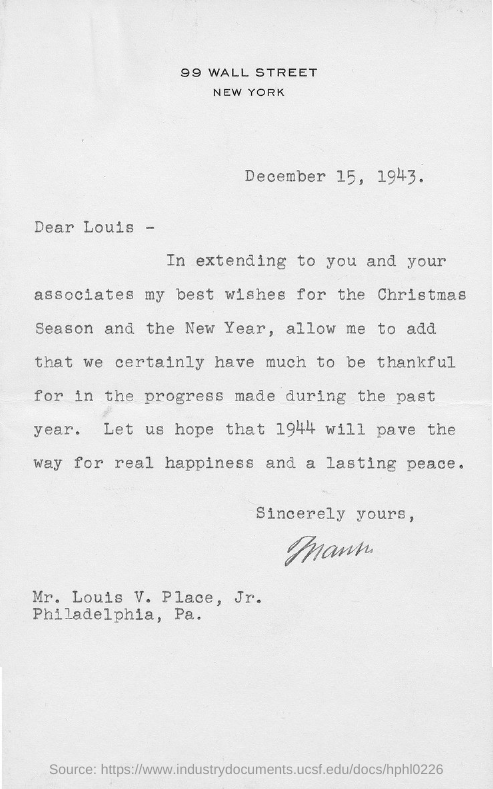Where is "99 WALL STREET" located ?
Offer a terse response. NEW YORK. What is the date mentioned in the letter?
Offer a terse response. December 15 ,  1943. This letter addressed to whom?
Keep it short and to the point. Mr. Louis V. Place ,Jr. "Mr. Louis  V.  Place , Jr" is residing in which place?
Offer a very short reply. Philadelphia, pa. Which year they are hoping WILL PAVE THE WAY FOR REAL HAPPINESS?
Keep it short and to the point. 1944. "Best wishes for" what is mentioned in the letter?
Your answer should be very brief. For the christmas season and the new year. 